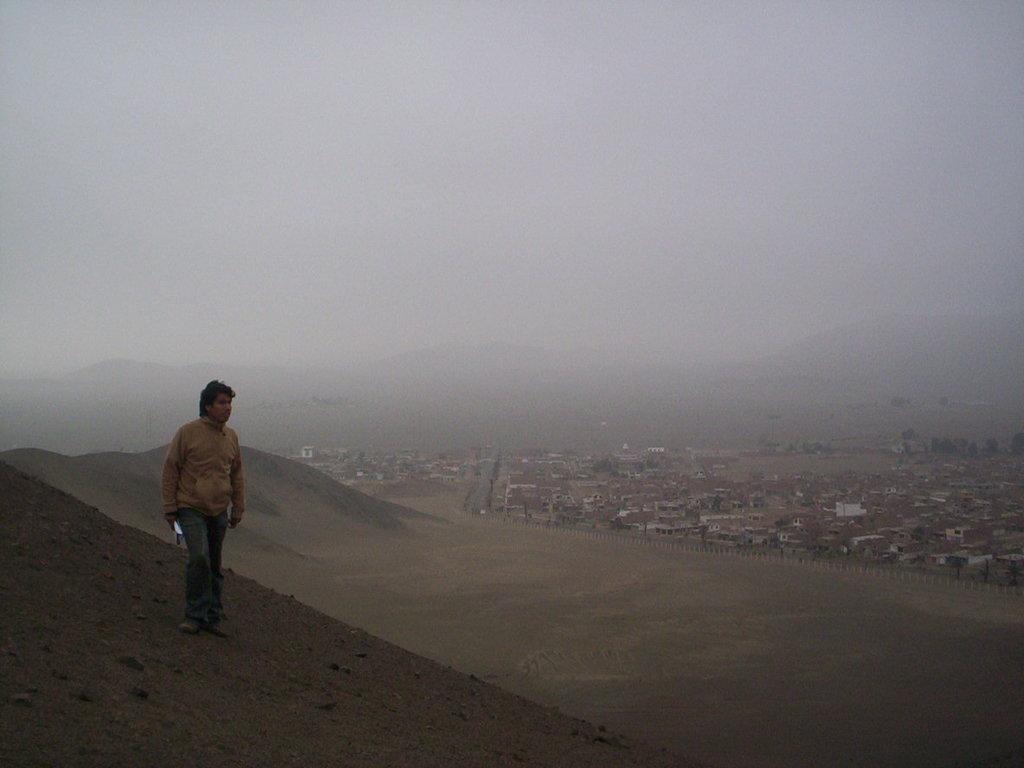Please provide a concise description of this image. There is man standing and holding an object and we can see hill. In the background we can see houses and sky. 